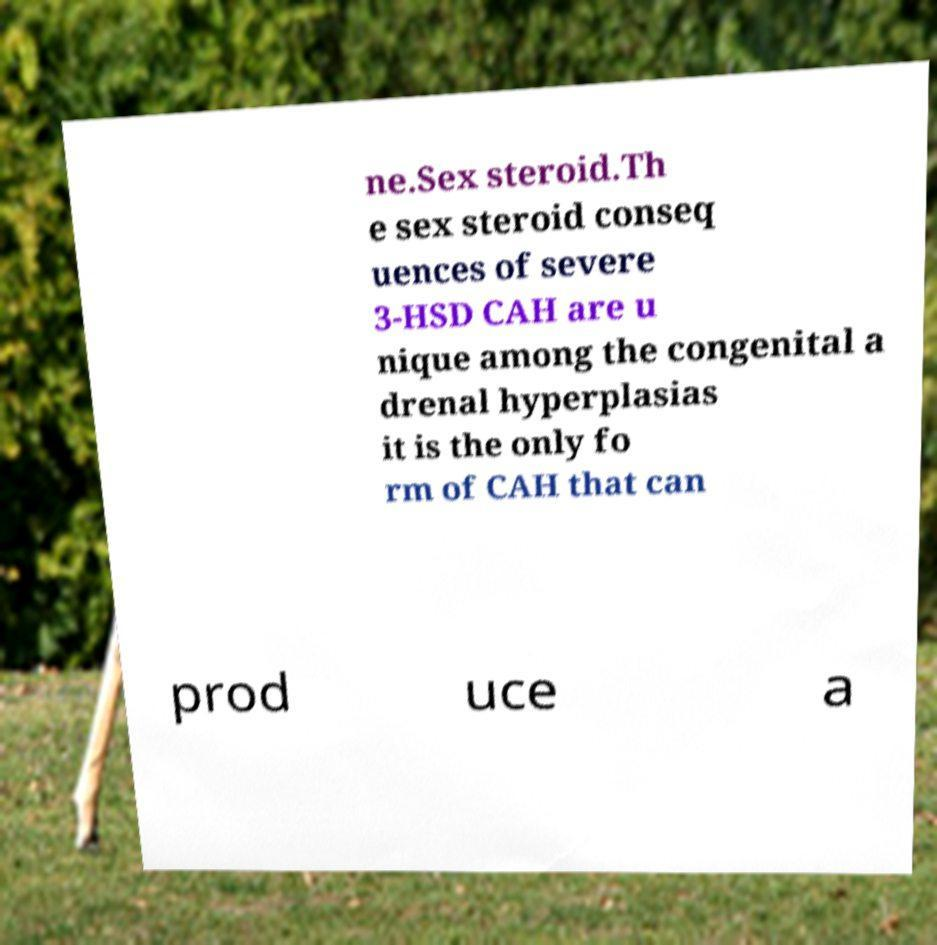Can you accurately transcribe the text from the provided image for me? ne.Sex steroid.Th e sex steroid conseq uences of severe 3-HSD CAH are u nique among the congenital a drenal hyperplasias it is the only fo rm of CAH that can prod uce a 